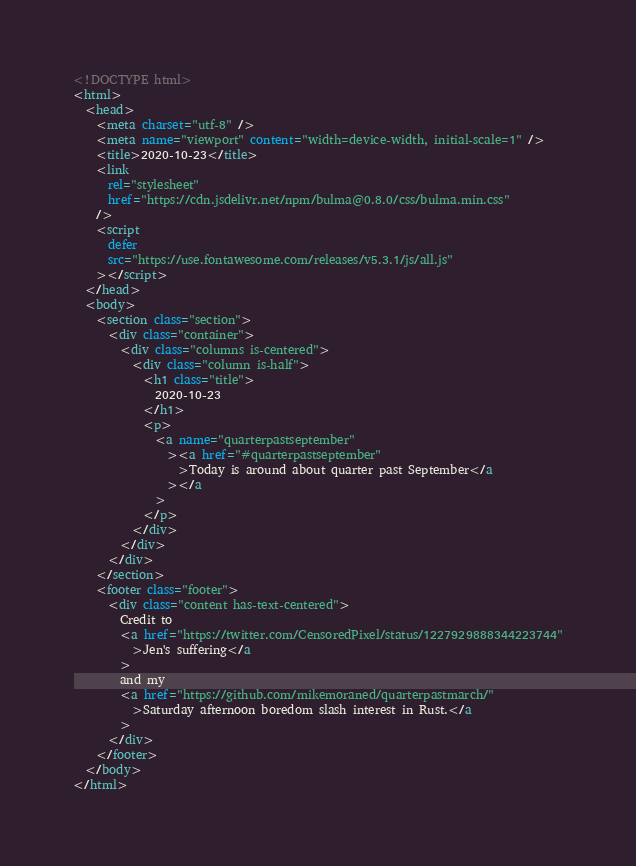Convert code to text. <code><loc_0><loc_0><loc_500><loc_500><_HTML_><!DOCTYPE html>
<html>
  <head>
    <meta charset="utf-8" />
    <meta name="viewport" content="width=device-width, initial-scale=1" />
    <title>2020-10-23</title>
    <link
      rel="stylesheet"
      href="https://cdn.jsdelivr.net/npm/bulma@0.8.0/css/bulma.min.css"
    />
    <script
      defer
      src="https://use.fontawesome.com/releases/v5.3.1/js/all.js"
    ></script>
  </head>
  <body>
    <section class="section">
      <div class="container">
        <div class="columns is-centered">
          <div class="column is-half">
            <h1 class="title">
              2020-10-23
            </h1>
            <p>
              <a name="quarterpastseptember"
                ><a href="#quarterpastseptember"
                  >Today is around about quarter past September</a
                ></a
              >
            </p>
          </div>
        </div>
      </div>
    </section>
    <footer class="footer">
      <div class="content has-text-centered">
        Credit to
        <a href="https://twitter.com/CensoredPixel/status/1227929888344223744"
          >Jen's suffering</a
        >
        and my
        <a href="https://github.com/mikemoraned/quarterpastmarch/"
          >Saturday afternoon boredom slash interest in Rust.</a
        >
      </div>
    </footer>
  </body>
</html></code> 